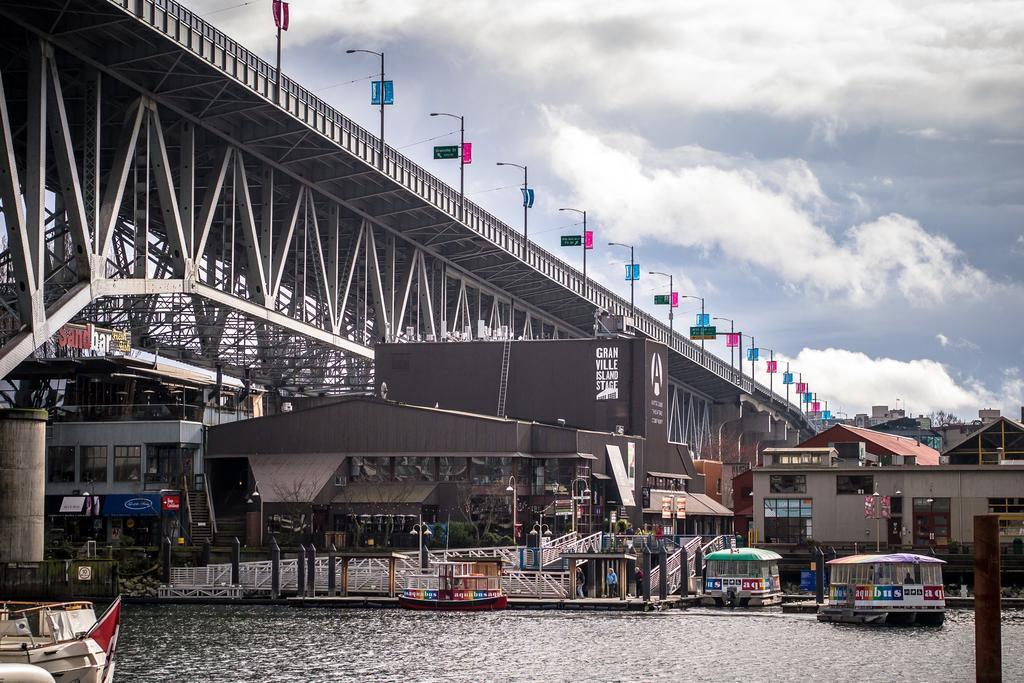Could you give a brief overview of what you see in this image? In this image we can see a few ships and boats on the water, there are some buildings, poles, windows, lights, sign boards, fence and boards, also we can see a bridge. In the background, we can see the sky with clouds. 